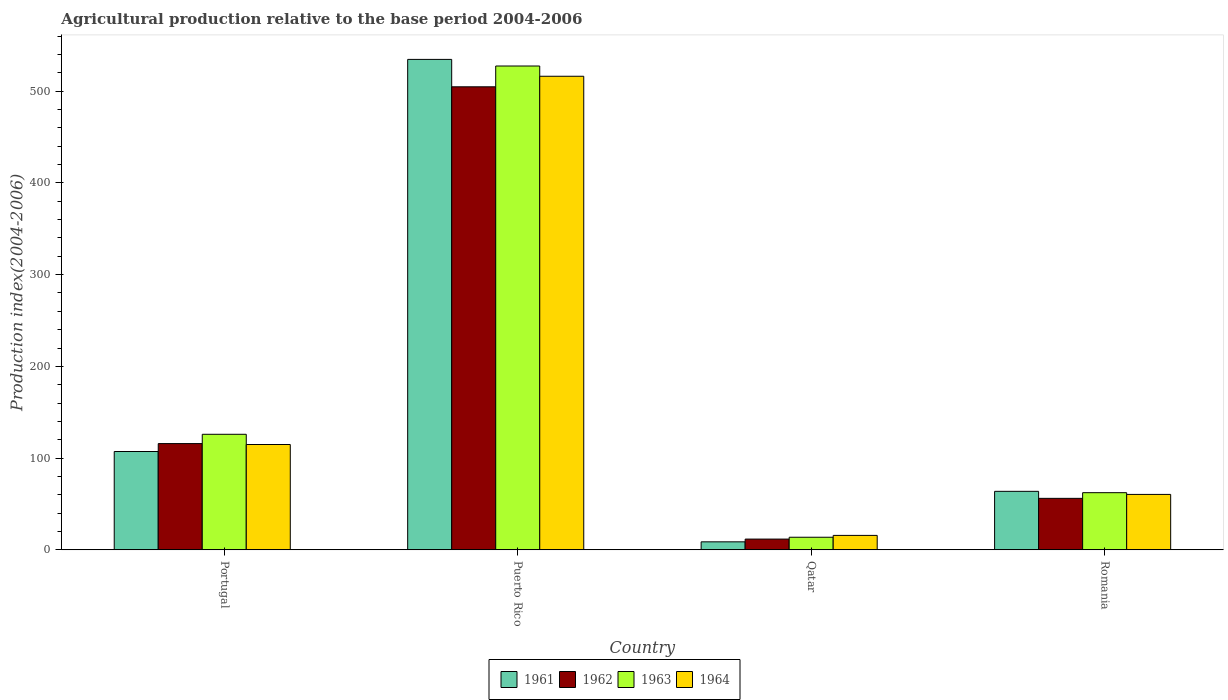How many groups of bars are there?
Provide a succinct answer. 4. Are the number of bars per tick equal to the number of legend labels?
Your response must be concise. Yes. How many bars are there on the 2nd tick from the left?
Give a very brief answer. 4. What is the label of the 2nd group of bars from the left?
Give a very brief answer. Puerto Rico. What is the agricultural production index in 1961 in Romania?
Offer a very short reply. 63.77. Across all countries, what is the maximum agricultural production index in 1964?
Your answer should be compact. 516.21. Across all countries, what is the minimum agricultural production index in 1962?
Give a very brief answer. 11.73. In which country was the agricultural production index in 1962 maximum?
Give a very brief answer. Puerto Rico. In which country was the agricultural production index in 1962 minimum?
Your response must be concise. Qatar. What is the total agricultural production index in 1963 in the graph?
Your response must be concise. 729.37. What is the difference between the agricultural production index in 1961 in Portugal and that in Romania?
Offer a very short reply. 43.41. What is the difference between the agricultural production index in 1964 in Romania and the agricultural production index in 1961 in Puerto Rico?
Offer a terse response. -474.17. What is the average agricultural production index in 1961 per country?
Your answer should be very brief. 178.56. What is the difference between the agricultural production index of/in 1962 and agricultural production index of/in 1963 in Qatar?
Ensure brevity in your answer.  -2.01. In how many countries, is the agricultural production index in 1961 greater than 340?
Your answer should be very brief. 1. What is the ratio of the agricultural production index in 1962 in Portugal to that in Qatar?
Make the answer very short. 9.87. Is the agricultural production index in 1963 in Puerto Rico less than that in Romania?
Your answer should be compact. No. Is the difference between the agricultural production index in 1962 in Puerto Rico and Romania greater than the difference between the agricultural production index in 1963 in Puerto Rico and Romania?
Provide a succinct answer. No. What is the difference between the highest and the second highest agricultural production index in 1963?
Offer a very short reply. 63.65. What is the difference between the highest and the lowest agricultural production index in 1961?
Keep it short and to the point. 525.85. In how many countries, is the agricultural production index in 1962 greater than the average agricultural production index in 1962 taken over all countries?
Ensure brevity in your answer.  1. What does the 1st bar from the right in Romania represents?
Your answer should be very brief. 1964. Is it the case that in every country, the sum of the agricultural production index in 1962 and agricultural production index in 1964 is greater than the agricultural production index in 1963?
Your answer should be compact. Yes. How many countries are there in the graph?
Provide a short and direct response. 4. Are the values on the major ticks of Y-axis written in scientific E-notation?
Your answer should be very brief. No. Does the graph contain any zero values?
Make the answer very short. No. Does the graph contain grids?
Keep it short and to the point. No. How are the legend labels stacked?
Provide a short and direct response. Horizontal. What is the title of the graph?
Ensure brevity in your answer.  Agricultural production relative to the base period 2004-2006. Does "1988" appear as one of the legend labels in the graph?
Provide a short and direct response. No. What is the label or title of the Y-axis?
Ensure brevity in your answer.  Production index(2004-2006). What is the Production index(2004-2006) of 1961 in Portugal?
Keep it short and to the point. 107.18. What is the Production index(2004-2006) of 1962 in Portugal?
Offer a terse response. 115.82. What is the Production index(2004-2006) of 1963 in Portugal?
Offer a terse response. 125.95. What is the Production index(2004-2006) of 1964 in Portugal?
Offer a very short reply. 114.81. What is the Production index(2004-2006) in 1961 in Puerto Rico?
Your response must be concise. 534.58. What is the Production index(2004-2006) of 1962 in Puerto Rico?
Your response must be concise. 504.71. What is the Production index(2004-2006) in 1963 in Puerto Rico?
Provide a short and direct response. 527.38. What is the Production index(2004-2006) in 1964 in Puerto Rico?
Offer a very short reply. 516.21. What is the Production index(2004-2006) in 1961 in Qatar?
Make the answer very short. 8.73. What is the Production index(2004-2006) in 1962 in Qatar?
Offer a very short reply. 11.73. What is the Production index(2004-2006) in 1963 in Qatar?
Provide a succinct answer. 13.74. What is the Production index(2004-2006) of 1964 in Qatar?
Make the answer very short. 15.74. What is the Production index(2004-2006) in 1961 in Romania?
Your answer should be compact. 63.77. What is the Production index(2004-2006) of 1962 in Romania?
Provide a succinct answer. 56.13. What is the Production index(2004-2006) of 1963 in Romania?
Provide a succinct answer. 62.3. What is the Production index(2004-2006) in 1964 in Romania?
Make the answer very short. 60.41. Across all countries, what is the maximum Production index(2004-2006) in 1961?
Give a very brief answer. 534.58. Across all countries, what is the maximum Production index(2004-2006) in 1962?
Your answer should be compact. 504.71. Across all countries, what is the maximum Production index(2004-2006) in 1963?
Your answer should be very brief. 527.38. Across all countries, what is the maximum Production index(2004-2006) of 1964?
Provide a short and direct response. 516.21. Across all countries, what is the minimum Production index(2004-2006) of 1961?
Your answer should be very brief. 8.73. Across all countries, what is the minimum Production index(2004-2006) of 1962?
Your response must be concise. 11.73. Across all countries, what is the minimum Production index(2004-2006) of 1963?
Give a very brief answer. 13.74. Across all countries, what is the minimum Production index(2004-2006) in 1964?
Your answer should be very brief. 15.74. What is the total Production index(2004-2006) in 1961 in the graph?
Your answer should be compact. 714.26. What is the total Production index(2004-2006) in 1962 in the graph?
Offer a very short reply. 688.39. What is the total Production index(2004-2006) of 1963 in the graph?
Your answer should be very brief. 729.37. What is the total Production index(2004-2006) in 1964 in the graph?
Keep it short and to the point. 707.17. What is the difference between the Production index(2004-2006) in 1961 in Portugal and that in Puerto Rico?
Offer a very short reply. -427.4. What is the difference between the Production index(2004-2006) in 1962 in Portugal and that in Puerto Rico?
Offer a very short reply. -388.89. What is the difference between the Production index(2004-2006) of 1963 in Portugal and that in Puerto Rico?
Ensure brevity in your answer.  -401.43. What is the difference between the Production index(2004-2006) of 1964 in Portugal and that in Puerto Rico?
Your response must be concise. -401.4. What is the difference between the Production index(2004-2006) of 1961 in Portugal and that in Qatar?
Make the answer very short. 98.45. What is the difference between the Production index(2004-2006) of 1962 in Portugal and that in Qatar?
Ensure brevity in your answer.  104.09. What is the difference between the Production index(2004-2006) of 1963 in Portugal and that in Qatar?
Make the answer very short. 112.21. What is the difference between the Production index(2004-2006) of 1964 in Portugal and that in Qatar?
Provide a succinct answer. 99.07. What is the difference between the Production index(2004-2006) of 1961 in Portugal and that in Romania?
Keep it short and to the point. 43.41. What is the difference between the Production index(2004-2006) in 1962 in Portugal and that in Romania?
Your answer should be very brief. 59.69. What is the difference between the Production index(2004-2006) in 1963 in Portugal and that in Romania?
Make the answer very short. 63.65. What is the difference between the Production index(2004-2006) in 1964 in Portugal and that in Romania?
Keep it short and to the point. 54.4. What is the difference between the Production index(2004-2006) in 1961 in Puerto Rico and that in Qatar?
Offer a terse response. 525.85. What is the difference between the Production index(2004-2006) in 1962 in Puerto Rico and that in Qatar?
Give a very brief answer. 492.98. What is the difference between the Production index(2004-2006) in 1963 in Puerto Rico and that in Qatar?
Ensure brevity in your answer.  513.64. What is the difference between the Production index(2004-2006) of 1964 in Puerto Rico and that in Qatar?
Your answer should be very brief. 500.47. What is the difference between the Production index(2004-2006) of 1961 in Puerto Rico and that in Romania?
Keep it short and to the point. 470.81. What is the difference between the Production index(2004-2006) in 1962 in Puerto Rico and that in Romania?
Your answer should be very brief. 448.58. What is the difference between the Production index(2004-2006) in 1963 in Puerto Rico and that in Romania?
Provide a short and direct response. 465.08. What is the difference between the Production index(2004-2006) of 1964 in Puerto Rico and that in Romania?
Provide a succinct answer. 455.8. What is the difference between the Production index(2004-2006) in 1961 in Qatar and that in Romania?
Provide a short and direct response. -55.04. What is the difference between the Production index(2004-2006) of 1962 in Qatar and that in Romania?
Your answer should be compact. -44.4. What is the difference between the Production index(2004-2006) of 1963 in Qatar and that in Romania?
Offer a terse response. -48.56. What is the difference between the Production index(2004-2006) of 1964 in Qatar and that in Romania?
Offer a terse response. -44.67. What is the difference between the Production index(2004-2006) of 1961 in Portugal and the Production index(2004-2006) of 1962 in Puerto Rico?
Your answer should be very brief. -397.53. What is the difference between the Production index(2004-2006) of 1961 in Portugal and the Production index(2004-2006) of 1963 in Puerto Rico?
Keep it short and to the point. -420.2. What is the difference between the Production index(2004-2006) of 1961 in Portugal and the Production index(2004-2006) of 1964 in Puerto Rico?
Your response must be concise. -409.03. What is the difference between the Production index(2004-2006) in 1962 in Portugal and the Production index(2004-2006) in 1963 in Puerto Rico?
Your answer should be compact. -411.56. What is the difference between the Production index(2004-2006) of 1962 in Portugal and the Production index(2004-2006) of 1964 in Puerto Rico?
Ensure brevity in your answer.  -400.39. What is the difference between the Production index(2004-2006) of 1963 in Portugal and the Production index(2004-2006) of 1964 in Puerto Rico?
Give a very brief answer. -390.26. What is the difference between the Production index(2004-2006) of 1961 in Portugal and the Production index(2004-2006) of 1962 in Qatar?
Ensure brevity in your answer.  95.45. What is the difference between the Production index(2004-2006) in 1961 in Portugal and the Production index(2004-2006) in 1963 in Qatar?
Provide a short and direct response. 93.44. What is the difference between the Production index(2004-2006) in 1961 in Portugal and the Production index(2004-2006) in 1964 in Qatar?
Offer a very short reply. 91.44. What is the difference between the Production index(2004-2006) in 1962 in Portugal and the Production index(2004-2006) in 1963 in Qatar?
Ensure brevity in your answer.  102.08. What is the difference between the Production index(2004-2006) in 1962 in Portugal and the Production index(2004-2006) in 1964 in Qatar?
Offer a terse response. 100.08. What is the difference between the Production index(2004-2006) of 1963 in Portugal and the Production index(2004-2006) of 1964 in Qatar?
Make the answer very short. 110.21. What is the difference between the Production index(2004-2006) of 1961 in Portugal and the Production index(2004-2006) of 1962 in Romania?
Your answer should be very brief. 51.05. What is the difference between the Production index(2004-2006) of 1961 in Portugal and the Production index(2004-2006) of 1963 in Romania?
Your response must be concise. 44.88. What is the difference between the Production index(2004-2006) of 1961 in Portugal and the Production index(2004-2006) of 1964 in Romania?
Provide a succinct answer. 46.77. What is the difference between the Production index(2004-2006) in 1962 in Portugal and the Production index(2004-2006) in 1963 in Romania?
Provide a short and direct response. 53.52. What is the difference between the Production index(2004-2006) in 1962 in Portugal and the Production index(2004-2006) in 1964 in Romania?
Offer a very short reply. 55.41. What is the difference between the Production index(2004-2006) of 1963 in Portugal and the Production index(2004-2006) of 1964 in Romania?
Make the answer very short. 65.54. What is the difference between the Production index(2004-2006) in 1961 in Puerto Rico and the Production index(2004-2006) in 1962 in Qatar?
Provide a succinct answer. 522.85. What is the difference between the Production index(2004-2006) of 1961 in Puerto Rico and the Production index(2004-2006) of 1963 in Qatar?
Ensure brevity in your answer.  520.84. What is the difference between the Production index(2004-2006) in 1961 in Puerto Rico and the Production index(2004-2006) in 1964 in Qatar?
Your answer should be compact. 518.84. What is the difference between the Production index(2004-2006) in 1962 in Puerto Rico and the Production index(2004-2006) in 1963 in Qatar?
Provide a succinct answer. 490.97. What is the difference between the Production index(2004-2006) of 1962 in Puerto Rico and the Production index(2004-2006) of 1964 in Qatar?
Keep it short and to the point. 488.97. What is the difference between the Production index(2004-2006) of 1963 in Puerto Rico and the Production index(2004-2006) of 1964 in Qatar?
Give a very brief answer. 511.64. What is the difference between the Production index(2004-2006) in 1961 in Puerto Rico and the Production index(2004-2006) in 1962 in Romania?
Your answer should be very brief. 478.45. What is the difference between the Production index(2004-2006) of 1961 in Puerto Rico and the Production index(2004-2006) of 1963 in Romania?
Provide a short and direct response. 472.28. What is the difference between the Production index(2004-2006) of 1961 in Puerto Rico and the Production index(2004-2006) of 1964 in Romania?
Make the answer very short. 474.17. What is the difference between the Production index(2004-2006) of 1962 in Puerto Rico and the Production index(2004-2006) of 1963 in Romania?
Offer a very short reply. 442.41. What is the difference between the Production index(2004-2006) in 1962 in Puerto Rico and the Production index(2004-2006) in 1964 in Romania?
Give a very brief answer. 444.3. What is the difference between the Production index(2004-2006) in 1963 in Puerto Rico and the Production index(2004-2006) in 1964 in Romania?
Offer a terse response. 466.97. What is the difference between the Production index(2004-2006) in 1961 in Qatar and the Production index(2004-2006) in 1962 in Romania?
Provide a succinct answer. -47.4. What is the difference between the Production index(2004-2006) in 1961 in Qatar and the Production index(2004-2006) in 1963 in Romania?
Keep it short and to the point. -53.57. What is the difference between the Production index(2004-2006) in 1961 in Qatar and the Production index(2004-2006) in 1964 in Romania?
Keep it short and to the point. -51.68. What is the difference between the Production index(2004-2006) in 1962 in Qatar and the Production index(2004-2006) in 1963 in Romania?
Make the answer very short. -50.57. What is the difference between the Production index(2004-2006) of 1962 in Qatar and the Production index(2004-2006) of 1964 in Romania?
Your answer should be very brief. -48.68. What is the difference between the Production index(2004-2006) of 1963 in Qatar and the Production index(2004-2006) of 1964 in Romania?
Your response must be concise. -46.67. What is the average Production index(2004-2006) in 1961 per country?
Give a very brief answer. 178.56. What is the average Production index(2004-2006) in 1962 per country?
Keep it short and to the point. 172.1. What is the average Production index(2004-2006) of 1963 per country?
Your answer should be compact. 182.34. What is the average Production index(2004-2006) of 1964 per country?
Make the answer very short. 176.79. What is the difference between the Production index(2004-2006) in 1961 and Production index(2004-2006) in 1962 in Portugal?
Provide a succinct answer. -8.64. What is the difference between the Production index(2004-2006) in 1961 and Production index(2004-2006) in 1963 in Portugal?
Keep it short and to the point. -18.77. What is the difference between the Production index(2004-2006) of 1961 and Production index(2004-2006) of 1964 in Portugal?
Make the answer very short. -7.63. What is the difference between the Production index(2004-2006) in 1962 and Production index(2004-2006) in 1963 in Portugal?
Offer a terse response. -10.13. What is the difference between the Production index(2004-2006) in 1962 and Production index(2004-2006) in 1964 in Portugal?
Provide a succinct answer. 1.01. What is the difference between the Production index(2004-2006) in 1963 and Production index(2004-2006) in 1964 in Portugal?
Make the answer very short. 11.14. What is the difference between the Production index(2004-2006) in 1961 and Production index(2004-2006) in 1962 in Puerto Rico?
Your answer should be compact. 29.87. What is the difference between the Production index(2004-2006) in 1961 and Production index(2004-2006) in 1963 in Puerto Rico?
Offer a very short reply. 7.2. What is the difference between the Production index(2004-2006) in 1961 and Production index(2004-2006) in 1964 in Puerto Rico?
Offer a terse response. 18.37. What is the difference between the Production index(2004-2006) of 1962 and Production index(2004-2006) of 1963 in Puerto Rico?
Ensure brevity in your answer.  -22.67. What is the difference between the Production index(2004-2006) of 1963 and Production index(2004-2006) of 1964 in Puerto Rico?
Provide a succinct answer. 11.17. What is the difference between the Production index(2004-2006) in 1961 and Production index(2004-2006) in 1962 in Qatar?
Provide a short and direct response. -3. What is the difference between the Production index(2004-2006) of 1961 and Production index(2004-2006) of 1963 in Qatar?
Your answer should be very brief. -5.01. What is the difference between the Production index(2004-2006) in 1961 and Production index(2004-2006) in 1964 in Qatar?
Give a very brief answer. -7.01. What is the difference between the Production index(2004-2006) of 1962 and Production index(2004-2006) of 1963 in Qatar?
Make the answer very short. -2.01. What is the difference between the Production index(2004-2006) of 1962 and Production index(2004-2006) of 1964 in Qatar?
Give a very brief answer. -4.01. What is the difference between the Production index(2004-2006) in 1963 and Production index(2004-2006) in 1964 in Qatar?
Your response must be concise. -2. What is the difference between the Production index(2004-2006) in 1961 and Production index(2004-2006) in 1962 in Romania?
Make the answer very short. 7.64. What is the difference between the Production index(2004-2006) of 1961 and Production index(2004-2006) of 1963 in Romania?
Offer a very short reply. 1.47. What is the difference between the Production index(2004-2006) of 1961 and Production index(2004-2006) of 1964 in Romania?
Ensure brevity in your answer.  3.36. What is the difference between the Production index(2004-2006) in 1962 and Production index(2004-2006) in 1963 in Romania?
Your answer should be compact. -6.17. What is the difference between the Production index(2004-2006) of 1962 and Production index(2004-2006) of 1964 in Romania?
Provide a succinct answer. -4.28. What is the difference between the Production index(2004-2006) in 1963 and Production index(2004-2006) in 1964 in Romania?
Make the answer very short. 1.89. What is the ratio of the Production index(2004-2006) of 1961 in Portugal to that in Puerto Rico?
Your answer should be compact. 0.2. What is the ratio of the Production index(2004-2006) of 1962 in Portugal to that in Puerto Rico?
Make the answer very short. 0.23. What is the ratio of the Production index(2004-2006) in 1963 in Portugal to that in Puerto Rico?
Keep it short and to the point. 0.24. What is the ratio of the Production index(2004-2006) of 1964 in Portugal to that in Puerto Rico?
Ensure brevity in your answer.  0.22. What is the ratio of the Production index(2004-2006) of 1961 in Portugal to that in Qatar?
Your answer should be compact. 12.28. What is the ratio of the Production index(2004-2006) of 1962 in Portugal to that in Qatar?
Provide a short and direct response. 9.87. What is the ratio of the Production index(2004-2006) of 1963 in Portugal to that in Qatar?
Keep it short and to the point. 9.17. What is the ratio of the Production index(2004-2006) of 1964 in Portugal to that in Qatar?
Keep it short and to the point. 7.29. What is the ratio of the Production index(2004-2006) of 1961 in Portugal to that in Romania?
Offer a terse response. 1.68. What is the ratio of the Production index(2004-2006) in 1962 in Portugal to that in Romania?
Offer a very short reply. 2.06. What is the ratio of the Production index(2004-2006) in 1963 in Portugal to that in Romania?
Offer a very short reply. 2.02. What is the ratio of the Production index(2004-2006) of 1964 in Portugal to that in Romania?
Keep it short and to the point. 1.9. What is the ratio of the Production index(2004-2006) of 1961 in Puerto Rico to that in Qatar?
Give a very brief answer. 61.23. What is the ratio of the Production index(2004-2006) of 1962 in Puerto Rico to that in Qatar?
Make the answer very short. 43.03. What is the ratio of the Production index(2004-2006) of 1963 in Puerto Rico to that in Qatar?
Provide a short and direct response. 38.38. What is the ratio of the Production index(2004-2006) of 1964 in Puerto Rico to that in Qatar?
Offer a terse response. 32.8. What is the ratio of the Production index(2004-2006) of 1961 in Puerto Rico to that in Romania?
Provide a succinct answer. 8.38. What is the ratio of the Production index(2004-2006) of 1962 in Puerto Rico to that in Romania?
Ensure brevity in your answer.  8.99. What is the ratio of the Production index(2004-2006) in 1963 in Puerto Rico to that in Romania?
Provide a short and direct response. 8.47. What is the ratio of the Production index(2004-2006) of 1964 in Puerto Rico to that in Romania?
Offer a terse response. 8.55. What is the ratio of the Production index(2004-2006) in 1961 in Qatar to that in Romania?
Give a very brief answer. 0.14. What is the ratio of the Production index(2004-2006) in 1962 in Qatar to that in Romania?
Your answer should be very brief. 0.21. What is the ratio of the Production index(2004-2006) of 1963 in Qatar to that in Romania?
Your response must be concise. 0.22. What is the ratio of the Production index(2004-2006) in 1964 in Qatar to that in Romania?
Provide a succinct answer. 0.26. What is the difference between the highest and the second highest Production index(2004-2006) in 1961?
Offer a very short reply. 427.4. What is the difference between the highest and the second highest Production index(2004-2006) of 1962?
Your response must be concise. 388.89. What is the difference between the highest and the second highest Production index(2004-2006) in 1963?
Ensure brevity in your answer.  401.43. What is the difference between the highest and the second highest Production index(2004-2006) in 1964?
Your response must be concise. 401.4. What is the difference between the highest and the lowest Production index(2004-2006) in 1961?
Offer a terse response. 525.85. What is the difference between the highest and the lowest Production index(2004-2006) in 1962?
Provide a short and direct response. 492.98. What is the difference between the highest and the lowest Production index(2004-2006) of 1963?
Ensure brevity in your answer.  513.64. What is the difference between the highest and the lowest Production index(2004-2006) in 1964?
Ensure brevity in your answer.  500.47. 